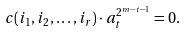Convert formula to latex. <formula><loc_0><loc_0><loc_500><loc_500>c ( i _ { 1 } , i _ { 2 } , \dots , i _ { r } ) \cdot a _ { t } ^ { 2 ^ { m - t - 1 } } & = 0 .</formula> 